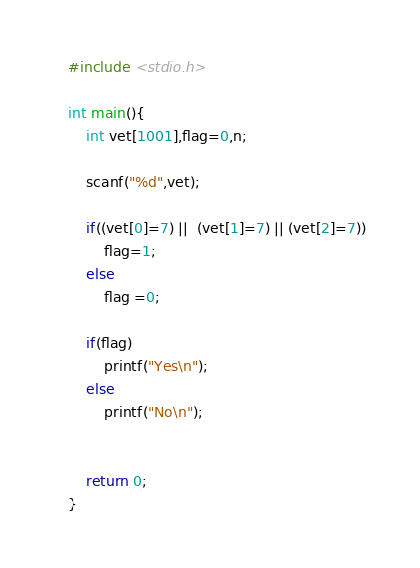Convert code to text. <code><loc_0><loc_0><loc_500><loc_500><_C_>#include <stdio.h>

int main(){
    int vet[1001],flag=0,n;

    scanf("%d",vet);

    if((vet[0]=7) ||  (vet[1]=7) || (vet[2]=7))
        flag=1;
    else
        flag =0;

    if(flag)
        printf("Yes\n");
    else
        printf("No\n");


    return 0;
}
</code> 